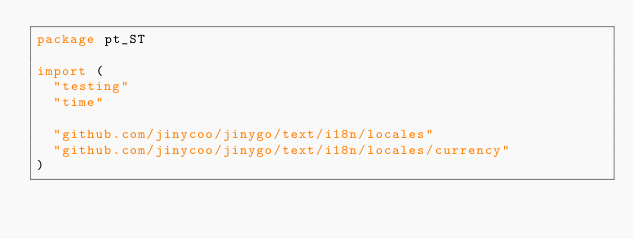<code> <loc_0><loc_0><loc_500><loc_500><_Go_>package pt_ST

import (
	"testing"
	"time"

	"github.com/jinycoo/jinygo/text/i18n/locales"
	"github.com/jinycoo/jinygo/text/i18n/locales/currency"
)
</code> 